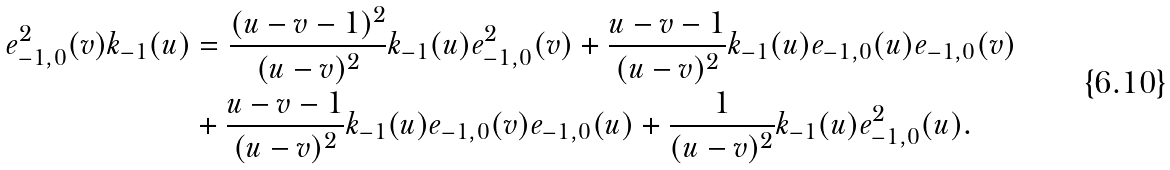Convert formula to latex. <formula><loc_0><loc_0><loc_500><loc_500>e ^ { 2 } _ { - 1 , 0 } ( v ) k _ { - 1 } ( u ) & = \frac { ( u - v - 1 ) ^ { 2 } } { ( u - v ) ^ { 2 } } k _ { - 1 } ( u ) e ^ { 2 } _ { - 1 , 0 } ( v ) + \frac { u - v - 1 } { ( u - v ) ^ { 2 } } k _ { - 1 } ( u ) e _ { - 1 , 0 } ( u ) e _ { - 1 , 0 } ( v ) \\ & + \frac { u - v - 1 } { ( u - v ) ^ { 2 } } k _ { - 1 } ( u ) e _ { - 1 , 0 } ( v ) e _ { - 1 , 0 } ( u ) + \frac { 1 } { ( u - v ) ^ { 2 } } k _ { - 1 } ( u ) e ^ { 2 } _ { - 1 , 0 } ( u ) . \\</formula> 